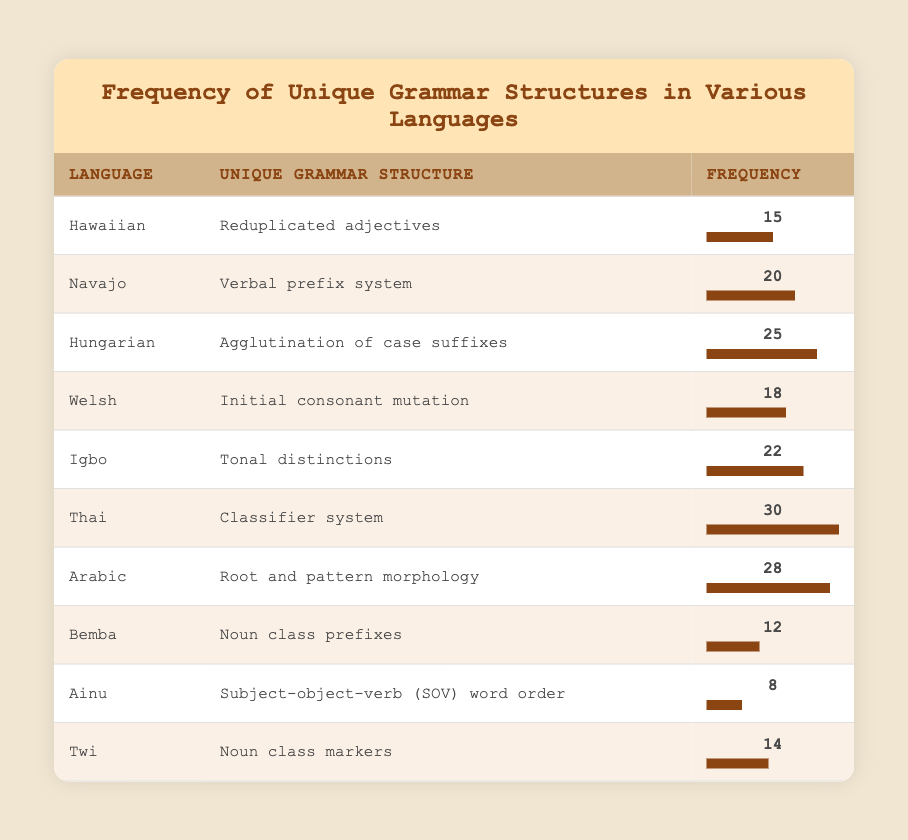What is the unique grammar structure of the Thai language? Referring to the table provided, the Thai language is associated with the unique grammar structure known as the classifier system.
Answer: Classifier system Which language has the highest frequency for its unique grammar structure? By scanning the frequency column, we find that the Thai language has the highest frequency of 30, indicating its unique grammar structure is most frequently noted among the languages listed.
Answer: Thai How many languages have a frequency of 20 or higher? By filtering the frequencies, the languages with a frequency of 20 or higher are: Navajo (20), Hungarian (25), Thai (30), and Arabic (28). Counting these, we find there are 4 languages.
Answer: 4 Is the frequency of the unique grammar structure for Igbo greater than that of Hawaiian? Comparing the two frequencies, Igbo has a frequency of 22, while Hawaiian has a frequency of 15. Since 22 is greater than 15, the statement is true.
Answer: Yes What is the average frequency of the unique grammar structures listed? To find the average, we sum the frequencies (15 + 20 + 25 + 18 + 22 + 30 + 28 + 12 + 8 + 14) =  222, then divide by the number of languages (10). Thus, the average is 222/10 = 22.2.
Answer: 22.2 Which language has a frequency closest to the median frequency of all languages? Sorting the frequencies in ascending order yields: 8, 12, 14, 15, 18, 20, 22, 25, 28, 30. The median of this even-numbered list is the average of the 5th and 6th values (18 and 20), which is 19. The language closest to 19 is Welsh, with a frequency of 18.
Answer: Welsh Are there any languages that have a unique grammar structure related to noun classes? Cross-referencing the table, we find that both Bemba (noun class prefixes) and Twi (noun class markers) have unique grammar structures related to noun classes.
Answer: Yes What is the difference in frequency between the unique grammar structures of Arabic and Ainu? Checking the frequencies, Arabic has a frequency of 28 and Ainu has a frequency of 8. The difference calculated is 28 - 8 = 20.
Answer: 20 